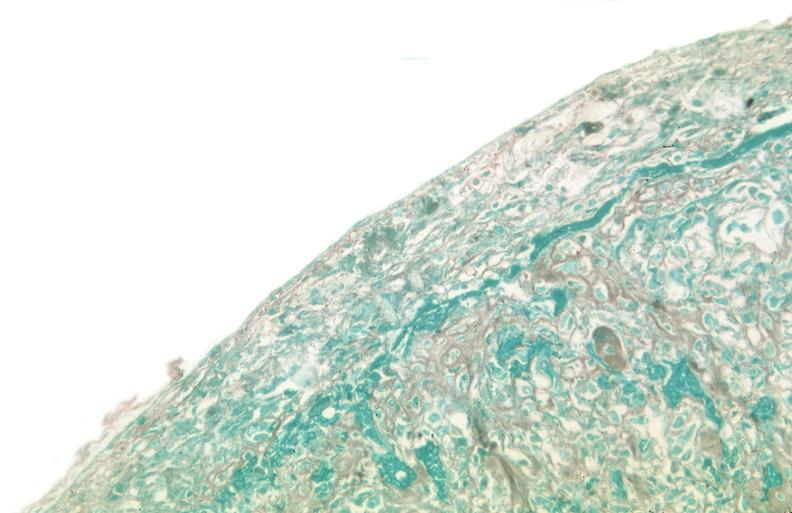what was talc used, alpha-1 antitrypsin deficiency?
Answer the question using a single word or phrase. Used to sclerose emphysematous lung 